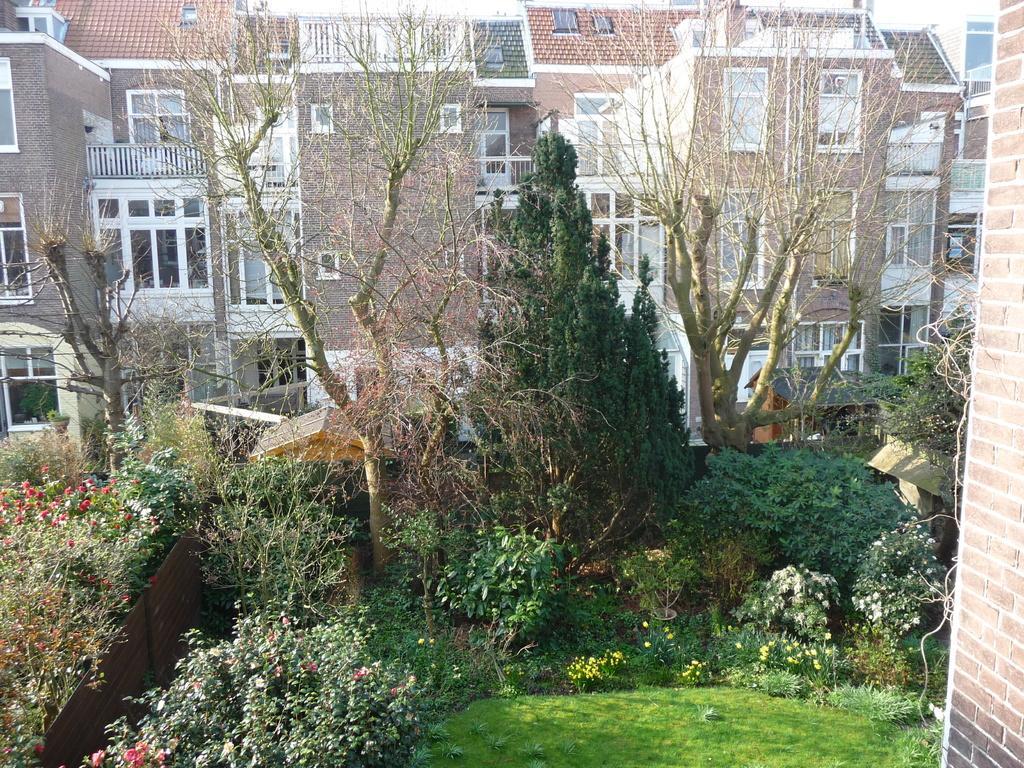In one or two sentences, can you explain what this image depicts? Here we can see plants, flowers, grass, and trees. In the background there are buildings. 